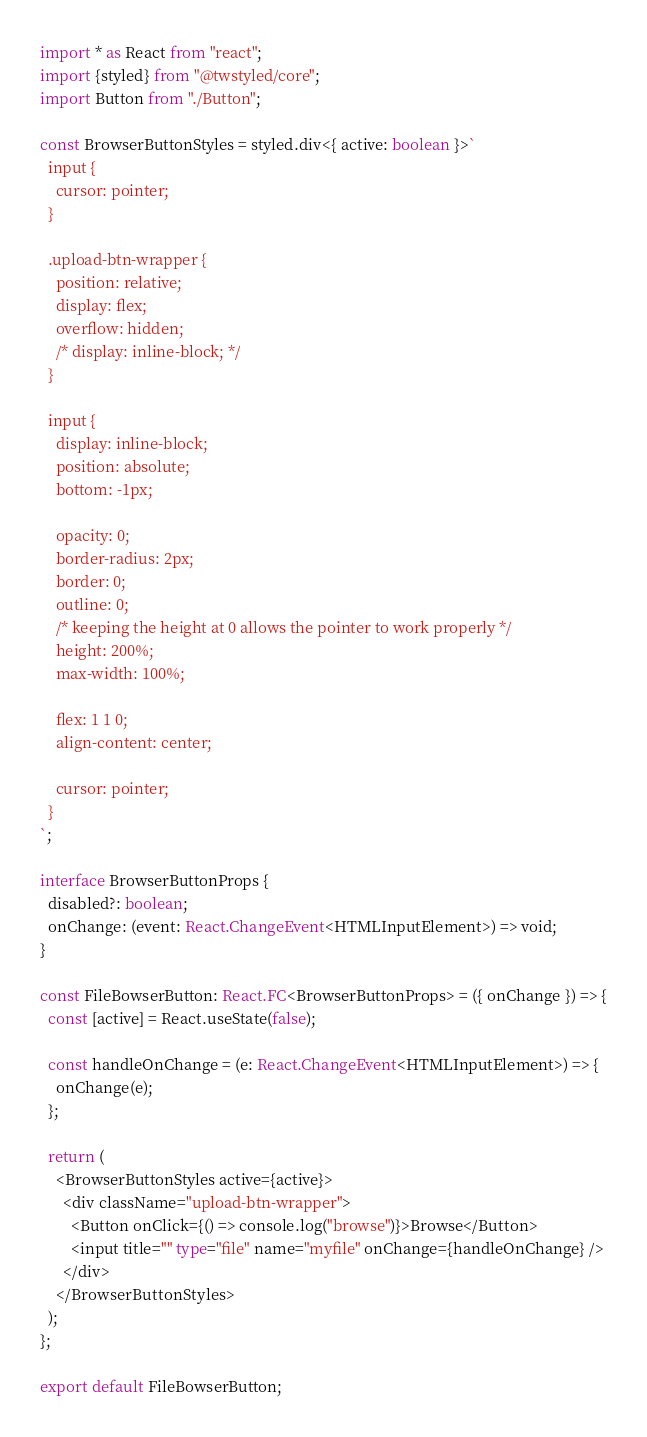<code> <loc_0><loc_0><loc_500><loc_500><_TypeScript_>import * as React from "react";
import {styled} from "@twstyled/core";
import Button from "./Button";

const BrowserButtonStyles = styled.div<{ active: boolean }>`
  input {
    cursor: pointer;
  }

  .upload-btn-wrapper {
    position: relative;
    display: flex;
    overflow: hidden;
    /* display: inline-block; */
  }

  input {
    display: inline-block;
    position: absolute;
    bottom: -1px;

    opacity: 0;
    border-radius: 2px;
    border: 0;
    outline: 0;
    /* keeping the height at 0 allows the pointer to work properly */
    height: 200%;
    max-width: 100%;

    flex: 1 1 0;
    align-content: center;

    cursor: pointer;
  }
`;

interface BrowserButtonProps {
  disabled?: boolean;
  onChange: (event: React.ChangeEvent<HTMLInputElement>) => void;
}

const FileBowserButton: React.FC<BrowserButtonProps> = ({ onChange }) => {
  const [active] = React.useState(false);

  const handleOnChange = (e: React.ChangeEvent<HTMLInputElement>) => {
    onChange(e);
  };

  return (
    <BrowserButtonStyles active={active}>
      <div className="upload-btn-wrapper">
        <Button onClick={() => console.log("browse")}>Browse</Button>
        <input title="" type="file" name="myfile" onChange={handleOnChange} />
      </div>
    </BrowserButtonStyles>
  );
};

export default FileBowserButton;
</code> 